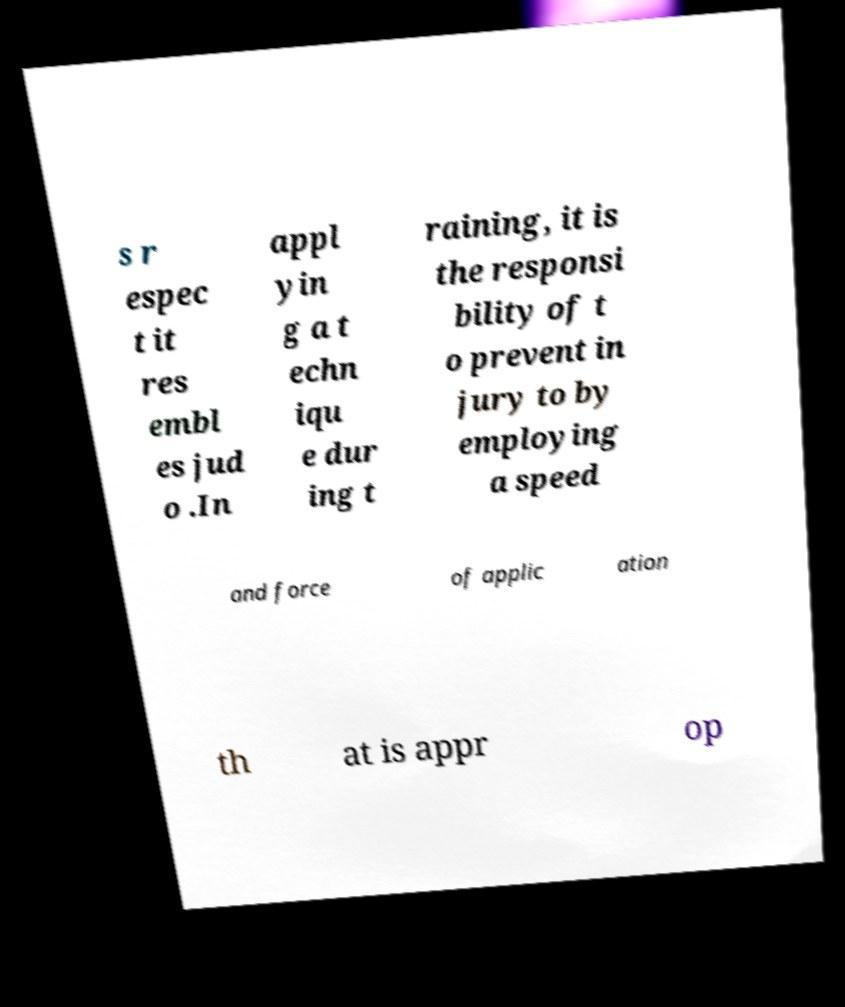Please read and relay the text visible in this image. What does it say? s r espec t it res embl es jud o .In appl yin g a t echn iqu e dur ing t raining, it is the responsi bility of t o prevent in jury to by employing a speed and force of applic ation th at is appr op 